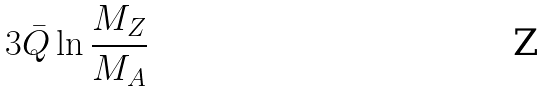Convert formula to latex. <formula><loc_0><loc_0><loc_500><loc_500>3 { \bar { Q } } \ln \frac { M _ { Z } } { M _ { A } }</formula> 